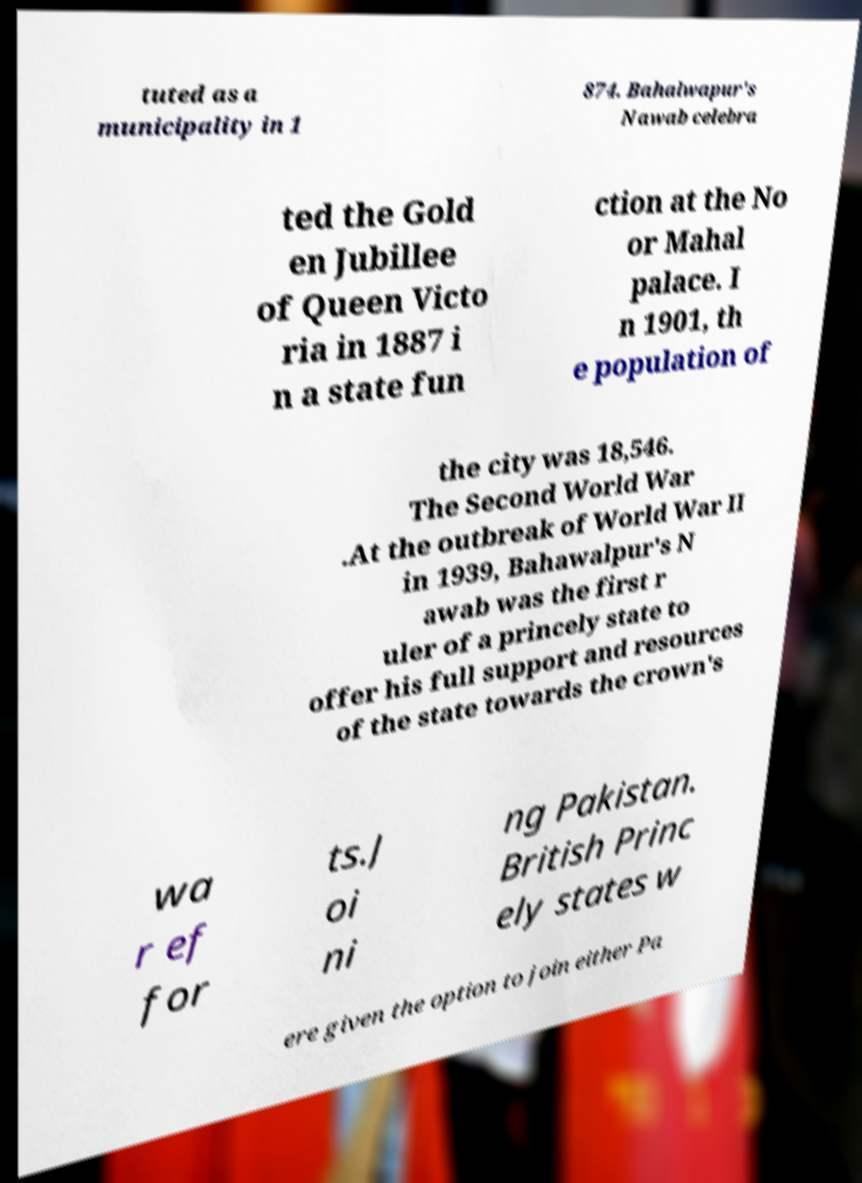Could you extract and type out the text from this image? tuted as a municipality in 1 874. Bahalwapur's Nawab celebra ted the Gold en Jubillee of Queen Victo ria in 1887 i n a state fun ction at the No or Mahal palace. I n 1901, th e population of the city was 18,546. The Second World War .At the outbreak of World War II in 1939, Bahawalpur's N awab was the first r uler of a princely state to offer his full support and resources of the state towards the crown's wa r ef for ts.J oi ni ng Pakistan. British Princ ely states w ere given the option to join either Pa 